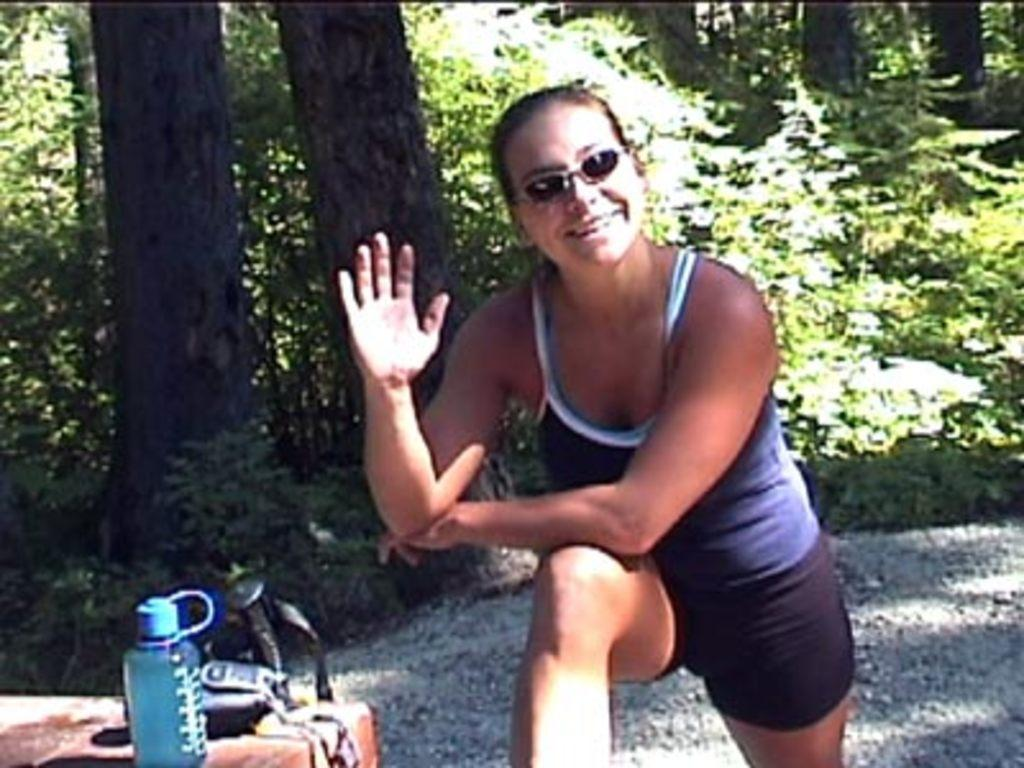Who is present in the image? There is a woman in the image. What is the woman wearing on her face? The woman is wearing goggles. What is the woman's facial expression? The woman is smiling. What can be seen near the bottom left side of the image? There is a bottle in the left side bottom of the image. What is located near the bottle? There are objects near the bottle. What is visible in the background of the image? The background of the image includes ground, trees, and plants. What type of plough is being used by the woman in the image? There is no plough present in the image; the woman is wearing goggles and smiling. What is the value of the objects near the bottle in the image? The value of the objects cannot be determined from the image alone, as value is subjective and depends on various factors. 